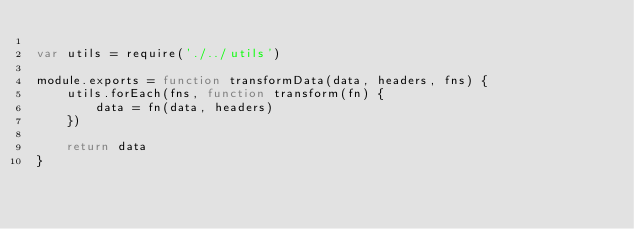Convert code to text. <code><loc_0><loc_0><loc_500><loc_500><_JavaScript_>
var utils = require('./../utils')

module.exports = function transformData(data, headers, fns) {
    utils.forEach(fns, function transform(fn) {
        data = fn(data, headers)
    })

    return data
}
</code> 